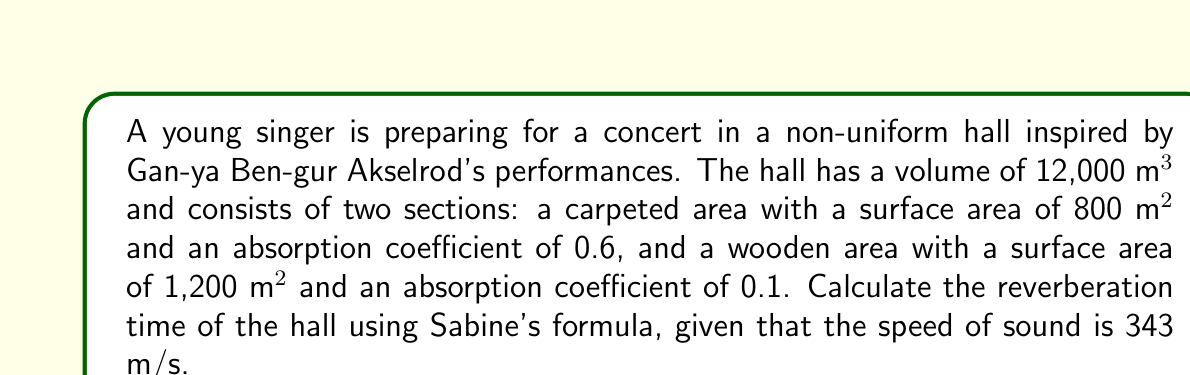Can you answer this question? To calculate the reverberation time in a non-uniform concert hall, we'll use Sabine's formula:

$$T = \frac{0.161V}{\sum S_i\alpha_i}$$

Where:
$T$ = reverberation time (s)
$V$ = volume of the room (m³)
$S_i$ = surface area of each material (m²)
$\alpha_i$ = absorption coefficient of each material

Given:
- Volume of the hall: $V = 12,000$ m³
- Carpeted area: $S_1 = 800$ m², $\alpha_1 = 0.6$
- Wooden area: $S_2 = 1,200$ m², $\alpha_2 = 0.1$
- Speed of sound: $c = 343$ m/s

Step 1: Calculate the total absorption ($$\sum S_i\alpha_i$$)
$$\sum S_i\alpha_i = S_1\alpha_1 + S_2\alpha_2$$
$$\sum S_i\alpha_i = (800 \times 0.6) + (1,200 \times 0.1)$$
$$\sum S_i\alpha_i = 480 + 120 = 600$$

Step 2: Apply Sabine's formula
$$T = \frac{0.161V}{\sum S_i\alpha_i}$$
$$T = \frac{0.161 \times 12,000}{600}$$
$$T = \frac{1,932}{600}$$
$$T = 3.22$$

Therefore, the reverberation time of the non-uniform concert hall is approximately 3.22 seconds.
Answer: 3.22 s 